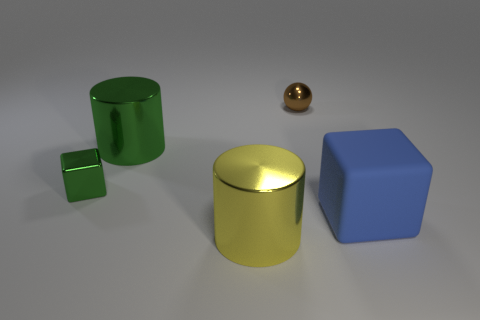Subtract all green cubes. Subtract all brown cylinders. How many cubes are left? 1 Add 2 purple metal blocks. How many objects exist? 7 Subtract all cylinders. How many objects are left? 3 Subtract all gray rubber balls. Subtract all green things. How many objects are left? 3 Add 2 big blocks. How many big blocks are left? 3 Add 4 big blue objects. How many big blue objects exist? 5 Subtract 0 purple cylinders. How many objects are left? 5 